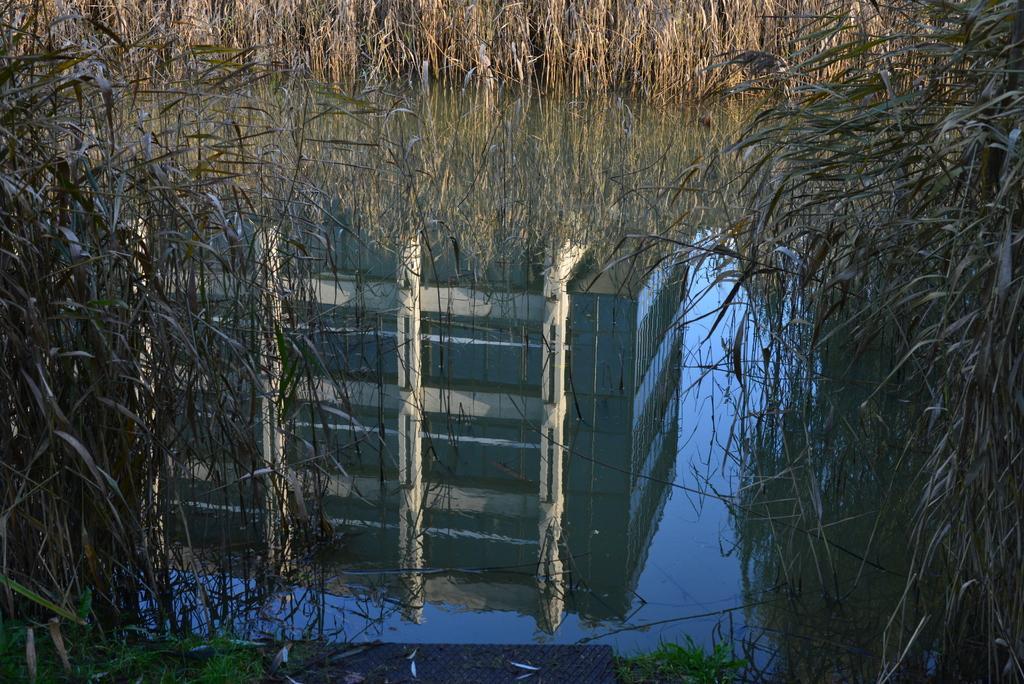Can you describe this image briefly? Here we can see plants and water. On the water we can see the reflection of a building. 